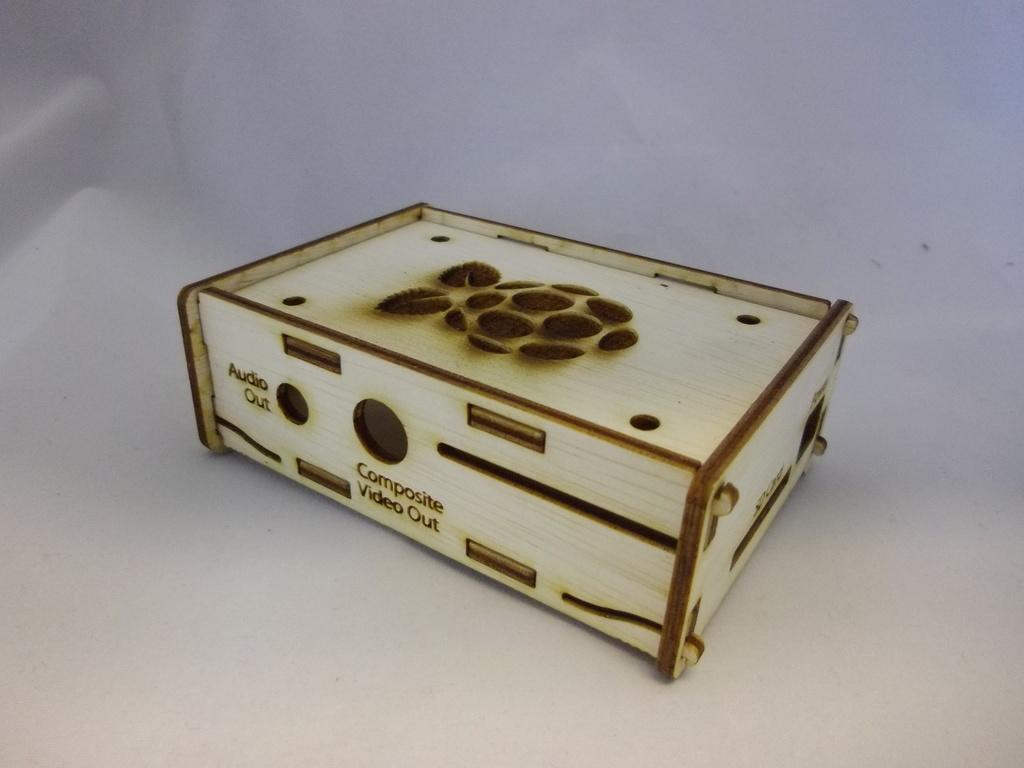<image>
Give a short and clear explanation of the subsequent image. a cream and brown box with composite video out written on the side 